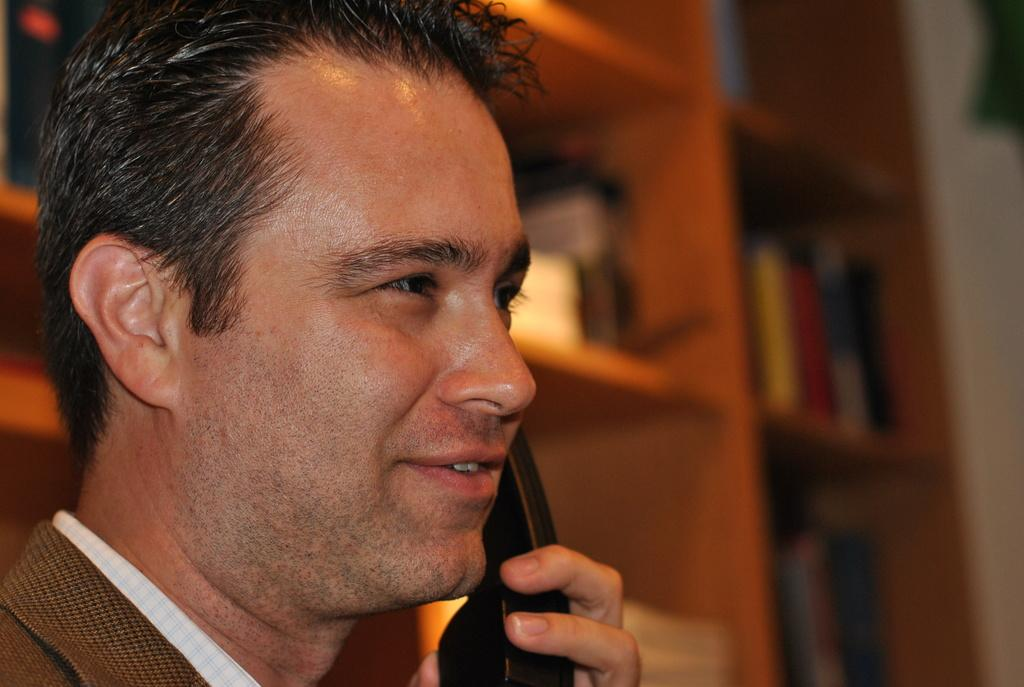What is the person in the image doing? The person is holding a telephone. What can be seen in the background of the image? There are objects in racks in the background of the image. How would you describe the background of the image? The background of the image is blurred. What type of string is the person using to talk on the telephone in the image? The person is not using any string to talk on the telephone in the image; they are likely using a wireless or cordless phone. 